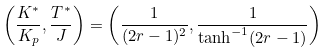Convert formula to latex. <formula><loc_0><loc_0><loc_500><loc_500>\left ( \frac { K ^ { * } } { K _ { p } } , \frac { T ^ { * } } { J } \right ) = \left ( \frac { 1 } { ( 2 r - 1 ) ^ { 2 } } , \frac { 1 } { \tanh ^ { - 1 } ( 2 r - 1 ) } \right )</formula> 